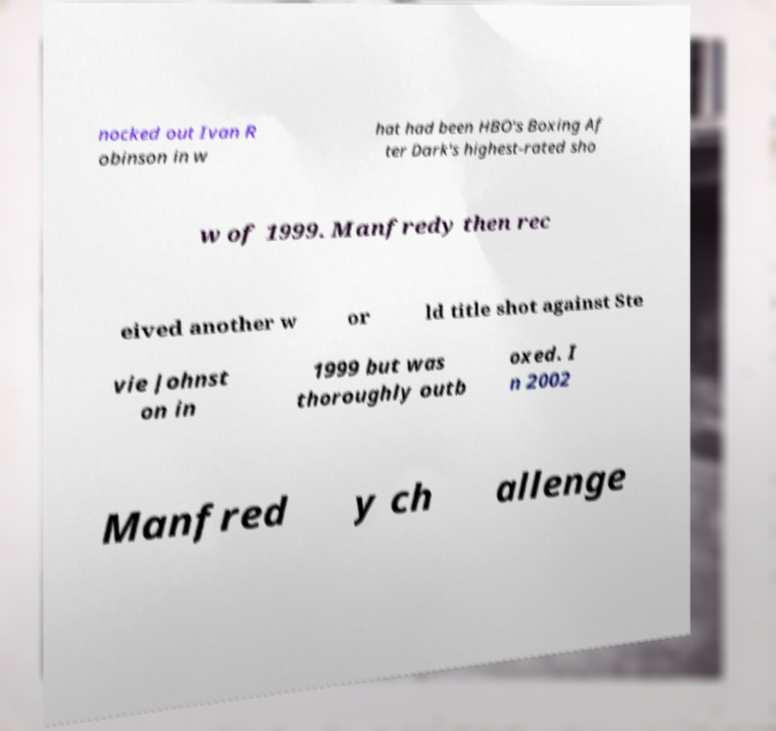I need the written content from this picture converted into text. Can you do that? nocked out Ivan R obinson in w hat had been HBO's Boxing Af ter Dark's highest-rated sho w of 1999. Manfredy then rec eived another w or ld title shot against Ste vie Johnst on in 1999 but was thoroughly outb oxed. I n 2002 Manfred y ch allenge 